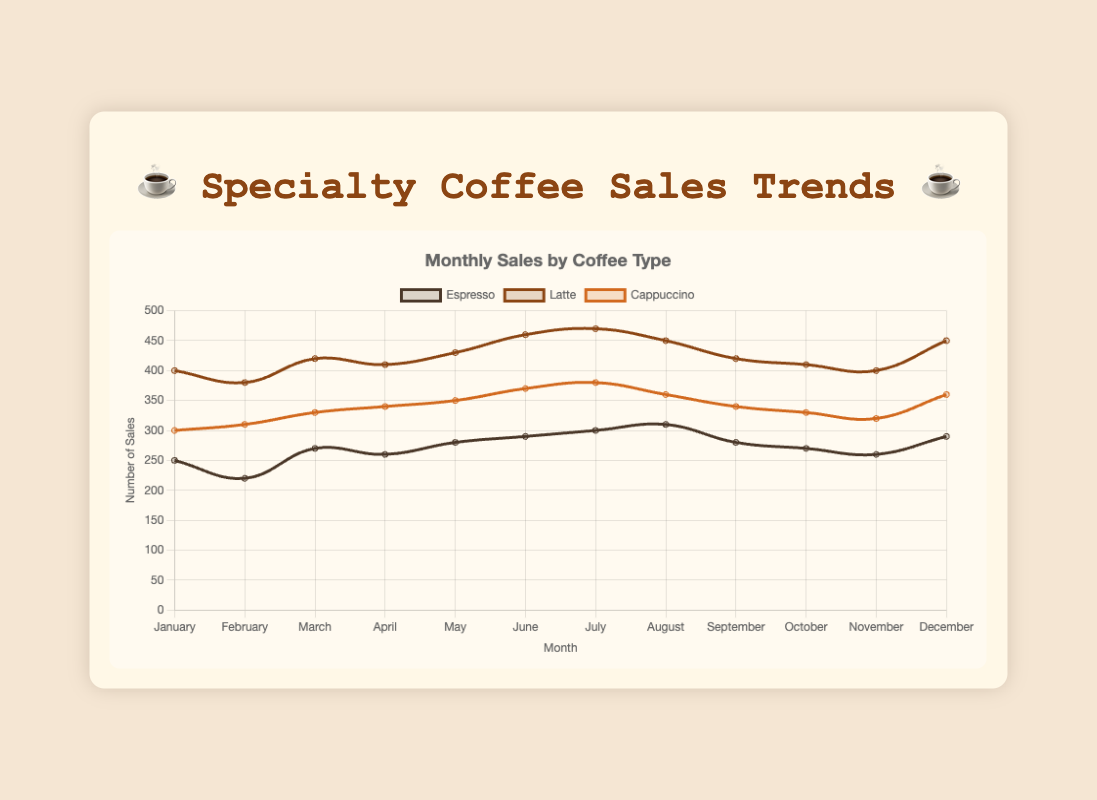Which coffee type had the highest sales in July? In July, Espresso had sales of 300, Latte had 470, and Cappuccino had 380. Comparing these values, Latte has the highest sales.
Answer: Latte In which month did Cappuccino sales peak? By examining Cappuccino's sales data for each month, it’s clear that the highest value is 380, which occurs in July.
Answer: July What's the average sales of Espresso over the year? To find the average sales of Espresso, sum all monthly sales: 250 + 220 + 270 + 260 + 280 + 290 + 300 + 310 + 280 + 270 + 260 + 290 = 3280. Then divide by 12 (months). 3280 / 12 = 273.33.
Answer: 273.33 Which month saw the lowest sales of Latte, and what were the sales numbers? By examining the sales data, the lowest sales for Latte are 380 in February.
Answer: February, 380 Compare the trend lines for Latte and Cappuccino from January to June. Which type shows a steeper increase? From the visual trends, in January Latte starts with 400 and ends in June at 460, an increase of 60. Cappuccino starts with 300 and ends at 370, an increase of 70. A steeper increase is seen in Cappuccino.
Answer: Cappuccino What is the difference in sales between Espresso and Cappuccino in May? In May, Espresso sales are 280 and Cappuccino sales are 350. The difference is 350 - 280 = 70.
Answer: 70 Which month had the most significant drop in Latte sales compared to the previous month? From July (470) to August (450), Latte sales dropped by 20. This is the most significant monthly drop observed.
Answer: August What is the combined sales of all coffee types in December? For December: Espresso = 290, Latte = 450, Cappuccino = 360. Summing these: 290 + 450 + 360 = 1100.
Answer: 1100 In which month did Espresso sales match those of Cappuccino? In November, Espresso sales are 260 and Cappuccino sales are also 260.
Answer: November How many months had Cappuccino sales higher than 350? By scanning through the Cappuccino data, the sales are higher than 350 in June, July, December. That totals 3 months.
Answer: 3 